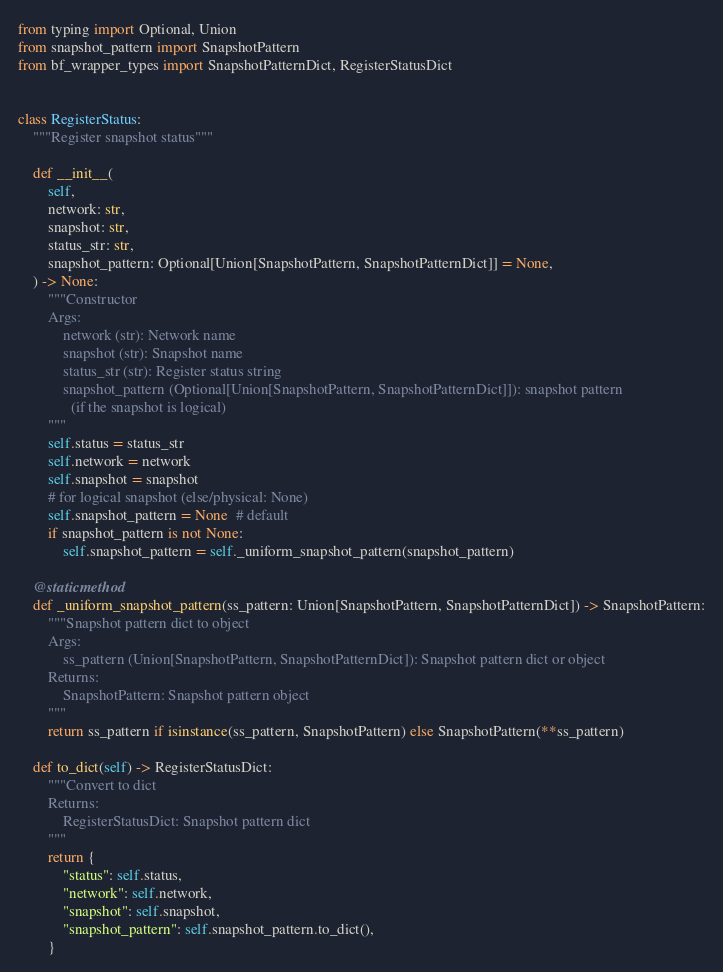<code> <loc_0><loc_0><loc_500><loc_500><_Python_>from typing import Optional, Union
from snapshot_pattern import SnapshotPattern
from bf_wrapper_types import SnapshotPatternDict, RegisterStatusDict


class RegisterStatus:
    """Register snapshot status"""

    def __init__(
        self,
        network: str,
        snapshot: str,
        status_str: str,
        snapshot_pattern: Optional[Union[SnapshotPattern, SnapshotPatternDict]] = None,
    ) -> None:
        """Constructor
        Args:
            network (str): Network name
            snapshot (str): Snapshot name
            status_str (str): Register status string
            snapshot_pattern (Optional[Union[SnapshotPattern, SnapshotPatternDict]]): snapshot pattern
              (if the snapshot is logical)
        """
        self.status = status_str
        self.network = network
        self.snapshot = snapshot
        # for logical snapshot (else/physical: None)
        self.snapshot_pattern = None  # default
        if snapshot_pattern is not None:
            self.snapshot_pattern = self._uniform_snapshot_pattern(snapshot_pattern)

    @staticmethod
    def _uniform_snapshot_pattern(ss_pattern: Union[SnapshotPattern, SnapshotPatternDict]) -> SnapshotPattern:
        """Snapshot pattern dict to object
        Args:
            ss_pattern (Union[SnapshotPattern, SnapshotPatternDict]): Snapshot pattern dict or object
        Returns:
            SnapshotPattern: Snapshot pattern object
        """
        return ss_pattern if isinstance(ss_pattern, SnapshotPattern) else SnapshotPattern(**ss_pattern)

    def to_dict(self) -> RegisterStatusDict:
        """Convert to dict
        Returns:
            RegisterStatusDict: Snapshot pattern dict
        """
        return {
            "status": self.status,
            "network": self.network,
            "snapshot": self.snapshot,
            "snapshot_pattern": self.snapshot_pattern.to_dict(),
        }
</code> 